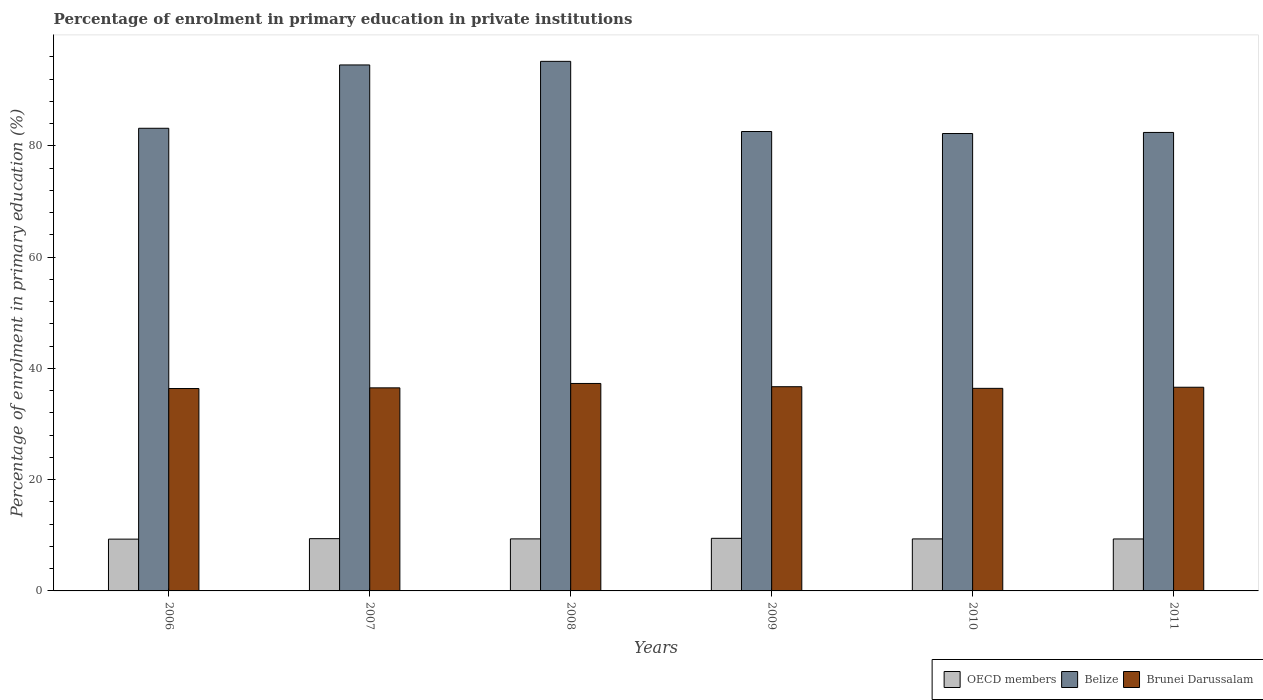How many groups of bars are there?
Keep it short and to the point. 6. Are the number of bars per tick equal to the number of legend labels?
Offer a terse response. Yes. How many bars are there on the 5th tick from the left?
Provide a short and direct response. 3. In how many cases, is the number of bars for a given year not equal to the number of legend labels?
Your response must be concise. 0. What is the percentage of enrolment in primary education in Belize in 2010?
Ensure brevity in your answer.  82.22. Across all years, what is the maximum percentage of enrolment in primary education in Brunei Darussalam?
Your response must be concise. 37.29. Across all years, what is the minimum percentage of enrolment in primary education in Brunei Darussalam?
Ensure brevity in your answer.  36.38. In which year was the percentage of enrolment in primary education in OECD members maximum?
Provide a succinct answer. 2009. What is the total percentage of enrolment in primary education in OECD members in the graph?
Your response must be concise. 56.2. What is the difference between the percentage of enrolment in primary education in Brunei Darussalam in 2007 and that in 2010?
Offer a terse response. 0.09. What is the difference between the percentage of enrolment in primary education in Brunei Darussalam in 2011 and the percentage of enrolment in primary education in Belize in 2008?
Your response must be concise. -58.58. What is the average percentage of enrolment in primary education in OECD members per year?
Your answer should be very brief. 9.37. In the year 2006, what is the difference between the percentage of enrolment in primary education in Brunei Darussalam and percentage of enrolment in primary education in Belize?
Provide a short and direct response. -46.78. What is the ratio of the percentage of enrolment in primary education in Brunei Darussalam in 2007 to that in 2008?
Your answer should be compact. 0.98. Is the percentage of enrolment in primary education in Belize in 2007 less than that in 2011?
Provide a succinct answer. No. Is the difference between the percentage of enrolment in primary education in Brunei Darussalam in 2007 and 2009 greater than the difference between the percentage of enrolment in primary education in Belize in 2007 and 2009?
Your answer should be compact. No. What is the difference between the highest and the second highest percentage of enrolment in primary education in OECD members?
Provide a succinct answer. 0.06. What is the difference between the highest and the lowest percentage of enrolment in primary education in Brunei Darussalam?
Make the answer very short. 0.91. In how many years, is the percentage of enrolment in primary education in OECD members greater than the average percentage of enrolment in primary education in OECD members taken over all years?
Give a very brief answer. 2. Is the sum of the percentage of enrolment in primary education in Belize in 2006 and 2007 greater than the maximum percentage of enrolment in primary education in OECD members across all years?
Provide a short and direct response. Yes. What does the 1st bar from the left in 2008 represents?
Ensure brevity in your answer.  OECD members. What does the 2nd bar from the right in 2007 represents?
Your answer should be compact. Belize. Is it the case that in every year, the sum of the percentage of enrolment in primary education in OECD members and percentage of enrolment in primary education in Brunei Darussalam is greater than the percentage of enrolment in primary education in Belize?
Ensure brevity in your answer.  No. How many bars are there?
Keep it short and to the point. 18. Are the values on the major ticks of Y-axis written in scientific E-notation?
Offer a terse response. No. How many legend labels are there?
Keep it short and to the point. 3. How are the legend labels stacked?
Offer a very short reply. Horizontal. What is the title of the graph?
Make the answer very short. Percentage of enrolment in primary education in private institutions. What is the label or title of the X-axis?
Ensure brevity in your answer.  Years. What is the label or title of the Y-axis?
Provide a short and direct response. Percentage of enrolment in primary education (%). What is the Percentage of enrolment in primary education (%) of OECD members in 2006?
Your answer should be compact. 9.31. What is the Percentage of enrolment in primary education (%) in Belize in 2006?
Offer a terse response. 83.16. What is the Percentage of enrolment in primary education (%) of Brunei Darussalam in 2006?
Your response must be concise. 36.38. What is the Percentage of enrolment in primary education (%) in OECD members in 2007?
Offer a terse response. 9.4. What is the Percentage of enrolment in primary education (%) in Belize in 2007?
Your answer should be compact. 94.55. What is the Percentage of enrolment in primary education (%) of Brunei Darussalam in 2007?
Make the answer very short. 36.5. What is the Percentage of enrolment in primary education (%) of OECD members in 2008?
Keep it short and to the point. 9.35. What is the Percentage of enrolment in primary education (%) in Belize in 2008?
Provide a short and direct response. 95.19. What is the Percentage of enrolment in primary education (%) of Brunei Darussalam in 2008?
Make the answer very short. 37.29. What is the Percentage of enrolment in primary education (%) of OECD members in 2009?
Your answer should be very brief. 9.45. What is the Percentage of enrolment in primary education (%) in Belize in 2009?
Keep it short and to the point. 82.58. What is the Percentage of enrolment in primary education (%) in Brunei Darussalam in 2009?
Your answer should be compact. 36.71. What is the Percentage of enrolment in primary education (%) of OECD members in 2010?
Your answer should be compact. 9.35. What is the Percentage of enrolment in primary education (%) in Belize in 2010?
Offer a very short reply. 82.22. What is the Percentage of enrolment in primary education (%) in Brunei Darussalam in 2010?
Make the answer very short. 36.41. What is the Percentage of enrolment in primary education (%) of OECD members in 2011?
Give a very brief answer. 9.34. What is the Percentage of enrolment in primary education (%) of Belize in 2011?
Ensure brevity in your answer.  82.41. What is the Percentage of enrolment in primary education (%) of Brunei Darussalam in 2011?
Provide a short and direct response. 36.61. Across all years, what is the maximum Percentage of enrolment in primary education (%) of OECD members?
Offer a very short reply. 9.45. Across all years, what is the maximum Percentage of enrolment in primary education (%) in Belize?
Your answer should be compact. 95.19. Across all years, what is the maximum Percentage of enrolment in primary education (%) of Brunei Darussalam?
Offer a terse response. 37.29. Across all years, what is the minimum Percentage of enrolment in primary education (%) in OECD members?
Provide a short and direct response. 9.31. Across all years, what is the minimum Percentage of enrolment in primary education (%) in Belize?
Provide a short and direct response. 82.22. Across all years, what is the minimum Percentage of enrolment in primary education (%) in Brunei Darussalam?
Your answer should be very brief. 36.38. What is the total Percentage of enrolment in primary education (%) in OECD members in the graph?
Give a very brief answer. 56.2. What is the total Percentage of enrolment in primary education (%) of Belize in the graph?
Ensure brevity in your answer.  520.1. What is the total Percentage of enrolment in primary education (%) in Brunei Darussalam in the graph?
Offer a very short reply. 219.91. What is the difference between the Percentage of enrolment in primary education (%) in OECD members in 2006 and that in 2007?
Offer a very short reply. -0.09. What is the difference between the Percentage of enrolment in primary education (%) in Belize in 2006 and that in 2007?
Offer a terse response. -11.38. What is the difference between the Percentage of enrolment in primary education (%) of Brunei Darussalam in 2006 and that in 2007?
Make the answer very short. -0.12. What is the difference between the Percentage of enrolment in primary education (%) in OECD members in 2006 and that in 2008?
Offer a very short reply. -0.05. What is the difference between the Percentage of enrolment in primary education (%) in Belize in 2006 and that in 2008?
Provide a short and direct response. -12.03. What is the difference between the Percentage of enrolment in primary education (%) of Brunei Darussalam in 2006 and that in 2008?
Offer a terse response. -0.91. What is the difference between the Percentage of enrolment in primary education (%) in OECD members in 2006 and that in 2009?
Your answer should be compact. -0.14. What is the difference between the Percentage of enrolment in primary education (%) in Belize in 2006 and that in 2009?
Offer a very short reply. 0.58. What is the difference between the Percentage of enrolment in primary education (%) in Brunei Darussalam in 2006 and that in 2009?
Your answer should be compact. -0.32. What is the difference between the Percentage of enrolment in primary education (%) in OECD members in 2006 and that in 2010?
Offer a terse response. -0.04. What is the difference between the Percentage of enrolment in primary education (%) in Belize in 2006 and that in 2010?
Make the answer very short. 0.95. What is the difference between the Percentage of enrolment in primary education (%) in Brunei Darussalam in 2006 and that in 2010?
Offer a very short reply. -0.03. What is the difference between the Percentage of enrolment in primary education (%) in OECD members in 2006 and that in 2011?
Your answer should be compact. -0.03. What is the difference between the Percentage of enrolment in primary education (%) in Belize in 2006 and that in 2011?
Your answer should be very brief. 0.75. What is the difference between the Percentage of enrolment in primary education (%) of Brunei Darussalam in 2006 and that in 2011?
Offer a terse response. -0.23. What is the difference between the Percentage of enrolment in primary education (%) of OECD members in 2007 and that in 2008?
Provide a short and direct response. 0.04. What is the difference between the Percentage of enrolment in primary education (%) in Belize in 2007 and that in 2008?
Make the answer very short. -0.64. What is the difference between the Percentage of enrolment in primary education (%) in Brunei Darussalam in 2007 and that in 2008?
Your answer should be compact. -0.79. What is the difference between the Percentage of enrolment in primary education (%) of OECD members in 2007 and that in 2009?
Your response must be concise. -0.06. What is the difference between the Percentage of enrolment in primary education (%) of Belize in 2007 and that in 2009?
Offer a very short reply. 11.97. What is the difference between the Percentage of enrolment in primary education (%) in Brunei Darussalam in 2007 and that in 2009?
Your answer should be compact. -0.2. What is the difference between the Percentage of enrolment in primary education (%) of OECD members in 2007 and that in 2010?
Provide a short and direct response. 0.05. What is the difference between the Percentage of enrolment in primary education (%) in Belize in 2007 and that in 2010?
Your response must be concise. 12.33. What is the difference between the Percentage of enrolment in primary education (%) in Brunei Darussalam in 2007 and that in 2010?
Ensure brevity in your answer.  0.09. What is the difference between the Percentage of enrolment in primary education (%) in OECD members in 2007 and that in 2011?
Make the answer very short. 0.06. What is the difference between the Percentage of enrolment in primary education (%) in Belize in 2007 and that in 2011?
Your answer should be compact. 12.13. What is the difference between the Percentage of enrolment in primary education (%) of Brunei Darussalam in 2007 and that in 2011?
Provide a short and direct response. -0.11. What is the difference between the Percentage of enrolment in primary education (%) of OECD members in 2008 and that in 2009?
Provide a succinct answer. -0.1. What is the difference between the Percentage of enrolment in primary education (%) in Belize in 2008 and that in 2009?
Your response must be concise. 12.61. What is the difference between the Percentage of enrolment in primary education (%) of Brunei Darussalam in 2008 and that in 2009?
Keep it short and to the point. 0.59. What is the difference between the Percentage of enrolment in primary education (%) of OECD members in 2008 and that in 2010?
Your response must be concise. 0.01. What is the difference between the Percentage of enrolment in primary education (%) in Belize in 2008 and that in 2010?
Offer a very short reply. 12.97. What is the difference between the Percentage of enrolment in primary education (%) in Brunei Darussalam in 2008 and that in 2010?
Your answer should be compact. 0.88. What is the difference between the Percentage of enrolment in primary education (%) in OECD members in 2008 and that in 2011?
Your answer should be compact. 0.01. What is the difference between the Percentage of enrolment in primary education (%) in Belize in 2008 and that in 2011?
Offer a terse response. 12.78. What is the difference between the Percentage of enrolment in primary education (%) of Brunei Darussalam in 2008 and that in 2011?
Ensure brevity in your answer.  0.68. What is the difference between the Percentage of enrolment in primary education (%) of OECD members in 2009 and that in 2010?
Your answer should be very brief. 0.11. What is the difference between the Percentage of enrolment in primary education (%) in Belize in 2009 and that in 2010?
Make the answer very short. 0.36. What is the difference between the Percentage of enrolment in primary education (%) in Brunei Darussalam in 2009 and that in 2010?
Offer a terse response. 0.3. What is the difference between the Percentage of enrolment in primary education (%) of OECD members in 2009 and that in 2011?
Keep it short and to the point. 0.11. What is the difference between the Percentage of enrolment in primary education (%) in Belize in 2009 and that in 2011?
Provide a short and direct response. 0.17. What is the difference between the Percentage of enrolment in primary education (%) of Brunei Darussalam in 2009 and that in 2011?
Your response must be concise. 0.09. What is the difference between the Percentage of enrolment in primary education (%) of OECD members in 2010 and that in 2011?
Your answer should be compact. 0.01. What is the difference between the Percentage of enrolment in primary education (%) in Belize in 2010 and that in 2011?
Your answer should be compact. -0.19. What is the difference between the Percentage of enrolment in primary education (%) in Brunei Darussalam in 2010 and that in 2011?
Provide a short and direct response. -0.2. What is the difference between the Percentage of enrolment in primary education (%) of OECD members in 2006 and the Percentage of enrolment in primary education (%) of Belize in 2007?
Ensure brevity in your answer.  -85.24. What is the difference between the Percentage of enrolment in primary education (%) of OECD members in 2006 and the Percentage of enrolment in primary education (%) of Brunei Darussalam in 2007?
Make the answer very short. -27.19. What is the difference between the Percentage of enrolment in primary education (%) in Belize in 2006 and the Percentage of enrolment in primary education (%) in Brunei Darussalam in 2007?
Ensure brevity in your answer.  46.66. What is the difference between the Percentage of enrolment in primary education (%) in OECD members in 2006 and the Percentage of enrolment in primary education (%) in Belize in 2008?
Your response must be concise. -85.88. What is the difference between the Percentage of enrolment in primary education (%) in OECD members in 2006 and the Percentage of enrolment in primary education (%) in Brunei Darussalam in 2008?
Make the answer very short. -27.98. What is the difference between the Percentage of enrolment in primary education (%) in Belize in 2006 and the Percentage of enrolment in primary education (%) in Brunei Darussalam in 2008?
Make the answer very short. 45.87. What is the difference between the Percentage of enrolment in primary education (%) in OECD members in 2006 and the Percentage of enrolment in primary education (%) in Belize in 2009?
Keep it short and to the point. -73.27. What is the difference between the Percentage of enrolment in primary education (%) of OECD members in 2006 and the Percentage of enrolment in primary education (%) of Brunei Darussalam in 2009?
Make the answer very short. -27.4. What is the difference between the Percentage of enrolment in primary education (%) of Belize in 2006 and the Percentage of enrolment in primary education (%) of Brunei Darussalam in 2009?
Your answer should be compact. 46.46. What is the difference between the Percentage of enrolment in primary education (%) in OECD members in 2006 and the Percentage of enrolment in primary education (%) in Belize in 2010?
Provide a short and direct response. -72.91. What is the difference between the Percentage of enrolment in primary education (%) in OECD members in 2006 and the Percentage of enrolment in primary education (%) in Brunei Darussalam in 2010?
Provide a short and direct response. -27.1. What is the difference between the Percentage of enrolment in primary education (%) in Belize in 2006 and the Percentage of enrolment in primary education (%) in Brunei Darussalam in 2010?
Your answer should be compact. 46.75. What is the difference between the Percentage of enrolment in primary education (%) in OECD members in 2006 and the Percentage of enrolment in primary education (%) in Belize in 2011?
Give a very brief answer. -73.1. What is the difference between the Percentage of enrolment in primary education (%) of OECD members in 2006 and the Percentage of enrolment in primary education (%) of Brunei Darussalam in 2011?
Your response must be concise. -27.3. What is the difference between the Percentage of enrolment in primary education (%) of Belize in 2006 and the Percentage of enrolment in primary education (%) of Brunei Darussalam in 2011?
Keep it short and to the point. 46.55. What is the difference between the Percentage of enrolment in primary education (%) in OECD members in 2007 and the Percentage of enrolment in primary education (%) in Belize in 2008?
Your answer should be compact. -85.79. What is the difference between the Percentage of enrolment in primary education (%) of OECD members in 2007 and the Percentage of enrolment in primary education (%) of Brunei Darussalam in 2008?
Your response must be concise. -27.9. What is the difference between the Percentage of enrolment in primary education (%) in Belize in 2007 and the Percentage of enrolment in primary education (%) in Brunei Darussalam in 2008?
Your answer should be compact. 57.25. What is the difference between the Percentage of enrolment in primary education (%) of OECD members in 2007 and the Percentage of enrolment in primary education (%) of Belize in 2009?
Offer a terse response. -73.18. What is the difference between the Percentage of enrolment in primary education (%) of OECD members in 2007 and the Percentage of enrolment in primary education (%) of Brunei Darussalam in 2009?
Give a very brief answer. -27.31. What is the difference between the Percentage of enrolment in primary education (%) in Belize in 2007 and the Percentage of enrolment in primary education (%) in Brunei Darussalam in 2009?
Keep it short and to the point. 57.84. What is the difference between the Percentage of enrolment in primary education (%) of OECD members in 2007 and the Percentage of enrolment in primary education (%) of Belize in 2010?
Your response must be concise. -72.82. What is the difference between the Percentage of enrolment in primary education (%) of OECD members in 2007 and the Percentage of enrolment in primary education (%) of Brunei Darussalam in 2010?
Give a very brief answer. -27.01. What is the difference between the Percentage of enrolment in primary education (%) in Belize in 2007 and the Percentage of enrolment in primary education (%) in Brunei Darussalam in 2010?
Your response must be concise. 58.13. What is the difference between the Percentage of enrolment in primary education (%) in OECD members in 2007 and the Percentage of enrolment in primary education (%) in Belize in 2011?
Offer a terse response. -73.01. What is the difference between the Percentage of enrolment in primary education (%) in OECD members in 2007 and the Percentage of enrolment in primary education (%) in Brunei Darussalam in 2011?
Provide a succinct answer. -27.22. What is the difference between the Percentage of enrolment in primary education (%) in Belize in 2007 and the Percentage of enrolment in primary education (%) in Brunei Darussalam in 2011?
Keep it short and to the point. 57.93. What is the difference between the Percentage of enrolment in primary education (%) of OECD members in 2008 and the Percentage of enrolment in primary education (%) of Belize in 2009?
Provide a succinct answer. -73.23. What is the difference between the Percentage of enrolment in primary education (%) in OECD members in 2008 and the Percentage of enrolment in primary education (%) in Brunei Darussalam in 2009?
Your answer should be very brief. -27.35. What is the difference between the Percentage of enrolment in primary education (%) of Belize in 2008 and the Percentage of enrolment in primary education (%) of Brunei Darussalam in 2009?
Your answer should be compact. 58.48. What is the difference between the Percentage of enrolment in primary education (%) in OECD members in 2008 and the Percentage of enrolment in primary education (%) in Belize in 2010?
Ensure brevity in your answer.  -72.86. What is the difference between the Percentage of enrolment in primary education (%) of OECD members in 2008 and the Percentage of enrolment in primary education (%) of Brunei Darussalam in 2010?
Ensure brevity in your answer.  -27.06. What is the difference between the Percentage of enrolment in primary education (%) in Belize in 2008 and the Percentage of enrolment in primary education (%) in Brunei Darussalam in 2010?
Your response must be concise. 58.78. What is the difference between the Percentage of enrolment in primary education (%) of OECD members in 2008 and the Percentage of enrolment in primary education (%) of Belize in 2011?
Your response must be concise. -73.06. What is the difference between the Percentage of enrolment in primary education (%) of OECD members in 2008 and the Percentage of enrolment in primary education (%) of Brunei Darussalam in 2011?
Offer a terse response. -27.26. What is the difference between the Percentage of enrolment in primary education (%) in Belize in 2008 and the Percentage of enrolment in primary education (%) in Brunei Darussalam in 2011?
Your response must be concise. 58.58. What is the difference between the Percentage of enrolment in primary education (%) in OECD members in 2009 and the Percentage of enrolment in primary education (%) in Belize in 2010?
Keep it short and to the point. -72.76. What is the difference between the Percentage of enrolment in primary education (%) of OECD members in 2009 and the Percentage of enrolment in primary education (%) of Brunei Darussalam in 2010?
Your answer should be very brief. -26.96. What is the difference between the Percentage of enrolment in primary education (%) in Belize in 2009 and the Percentage of enrolment in primary education (%) in Brunei Darussalam in 2010?
Provide a succinct answer. 46.17. What is the difference between the Percentage of enrolment in primary education (%) of OECD members in 2009 and the Percentage of enrolment in primary education (%) of Belize in 2011?
Your response must be concise. -72.96. What is the difference between the Percentage of enrolment in primary education (%) in OECD members in 2009 and the Percentage of enrolment in primary education (%) in Brunei Darussalam in 2011?
Your response must be concise. -27.16. What is the difference between the Percentage of enrolment in primary education (%) in Belize in 2009 and the Percentage of enrolment in primary education (%) in Brunei Darussalam in 2011?
Make the answer very short. 45.97. What is the difference between the Percentage of enrolment in primary education (%) in OECD members in 2010 and the Percentage of enrolment in primary education (%) in Belize in 2011?
Provide a succinct answer. -73.06. What is the difference between the Percentage of enrolment in primary education (%) in OECD members in 2010 and the Percentage of enrolment in primary education (%) in Brunei Darussalam in 2011?
Make the answer very short. -27.26. What is the difference between the Percentage of enrolment in primary education (%) of Belize in 2010 and the Percentage of enrolment in primary education (%) of Brunei Darussalam in 2011?
Provide a succinct answer. 45.6. What is the average Percentage of enrolment in primary education (%) in OECD members per year?
Give a very brief answer. 9.37. What is the average Percentage of enrolment in primary education (%) of Belize per year?
Ensure brevity in your answer.  86.68. What is the average Percentage of enrolment in primary education (%) in Brunei Darussalam per year?
Provide a short and direct response. 36.65. In the year 2006, what is the difference between the Percentage of enrolment in primary education (%) in OECD members and Percentage of enrolment in primary education (%) in Belize?
Offer a very short reply. -73.85. In the year 2006, what is the difference between the Percentage of enrolment in primary education (%) in OECD members and Percentage of enrolment in primary education (%) in Brunei Darussalam?
Keep it short and to the point. -27.07. In the year 2006, what is the difference between the Percentage of enrolment in primary education (%) in Belize and Percentage of enrolment in primary education (%) in Brunei Darussalam?
Your answer should be compact. 46.78. In the year 2007, what is the difference between the Percentage of enrolment in primary education (%) in OECD members and Percentage of enrolment in primary education (%) in Belize?
Offer a terse response. -85.15. In the year 2007, what is the difference between the Percentage of enrolment in primary education (%) of OECD members and Percentage of enrolment in primary education (%) of Brunei Darussalam?
Offer a terse response. -27.11. In the year 2007, what is the difference between the Percentage of enrolment in primary education (%) of Belize and Percentage of enrolment in primary education (%) of Brunei Darussalam?
Your answer should be compact. 58.04. In the year 2008, what is the difference between the Percentage of enrolment in primary education (%) of OECD members and Percentage of enrolment in primary education (%) of Belize?
Offer a terse response. -85.84. In the year 2008, what is the difference between the Percentage of enrolment in primary education (%) in OECD members and Percentage of enrolment in primary education (%) in Brunei Darussalam?
Give a very brief answer. -27.94. In the year 2008, what is the difference between the Percentage of enrolment in primary education (%) of Belize and Percentage of enrolment in primary education (%) of Brunei Darussalam?
Keep it short and to the point. 57.9. In the year 2009, what is the difference between the Percentage of enrolment in primary education (%) in OECD members and Percentage of enrolment in primary education (%) in Belize?
Your answer should be very brief. -73.13. In the year 2009, what is the difference between the Percentage of enrolment in primary education (%) in OECD members and Percentage of enrolment in primary education (%) in Brunei Darussalam?
Offer a terse response. -27.25. In the year 2009, what is the difference between the Percentage of enrolment in primary education (%) in Belize and Percentage of enrolment in primary education (%) in Brunei Darussalam?
Your response must be concise. 45.87. In the year 2010, what is the difference between the Percentage of enrolment in primary education (%) in OECD members and Percentage of enrolment in primary education (%) in Belize?
Your answer should be compact. -72.87. In the year 2010, what is the difference between the Percentage of enrolment in primary education (%) of OECD members and Percentage of enrolment in primary education (%) of Brunei Darussalam?
Ensure brevity in your answer.  -27.06. In the year 2010, what is the difference between the Percentage of enrolment in primary education (%) of Belize and Percentage of enrolment in primary education (%) of Brunei Darussalam?
Your answer should be very brief. 45.81. In the year 2011, what is the difference between the Percentage of enrolment in primary education (%) in OECD members and Percentage of enrolment in primary education (%) in Belize?
Give a very brief answer. -73.07. In the year 2011, what is the difference between the Percentage of enrolment in primary education (%) in OECD members and Percentage of enrolment in primary education (%) in Brunei Darussalam?
Keep it short and to the point. -27.27. In the year 2011, what is the difference between the Percentage of enrolment in primary education (%) in Belize and Percentage of enrolment in primary education (%) in Brunei Darussalam?
Keep it short and to the point. 45.8. What is the ratio of the Percentage of enrolment in primary education (%) in OECD members in 2006 to that in 2007?
Your response must be concise. 0.99. What is the ratio of the Percentage of enrolment in primary education (%) of Belize in 2006 to that in 2007?
Your response must be concise. 0.88. What is the ratio of the Percentage of enrolment in primary education (%) in OECD members in 2006 to that in 2008?
Ensure brevity in your answer.  1. What is the ratio of the Percentage of enrolment in primary education (%) of Belize in 2006 to that in 2008?
Your answer should be very brief. 0.87. What is the ratio of the Percentage of enrolment in primary education (%) of Brunei Darussalam in 2006 to that in 2008?
Offer a very short reply. 0.98. What is the ratio of the Percentage of enrolment in primary education (%) of OECD members in 2006 to that in 2009?
Your answer should be compact. 0.98. What is the ratio of the Percentage of enrolment in primary education (%) in Belize in 2006 to that in 2010?
Make the answer very short. 1.01. What is the ratio of the Percentage of enrolment in primary education (%) of OECD members in 2006 to that in 2011?
Offer a terse response. 1. What is the ratio of the Percentage of enrolment in primary education (%) in Belize in 2006 to that in 2011?
Make the answer very short. 1.01. What is the ratio of the Percentage of enrolment in primary education (%) of Brunei Darussalam in 2006 to that in 2011?
Make the answer very short. 0.99. What is the ratio of the Percentage of enrolment in primary education (%) of OECD members in 2007 to that in 2008?
Offer a terse response. 1. What is the ratio of the Percentage of enrolment in primary education (%) in Belize in 2007 to that in 2008?
Ensure brevity in your answer.  0.99. What is the ratio of the Percentage of enrolment in primary education (%) in Brunei Darussalam in 2007 to that in 2008?
Give a very brief answer. 0.98. What is the ratio of the Percentage of enrolment in primary education (%) in Belize in 2007 to that in 2009?
Your answer should be compact. 1.14. What is the ratio of the Percentage of enrolment in primary education (%) in OECD members in 2007 to that in 2010?
Make the answer very short. 1.01. What is the ratio of the Percentage of enrolment in primary education (%) of Belize in 2007 to that in 2010?
Provide a succinct answer. 1.15. What is the ratio of the Percentage of enrolment in primary education (%) of Brunei Darussalam in 2007 to that in 2010?
Offer a terse response. 1. What is the ratio of the Percentage of enrolment in primary education (%) of Belize in 2007 to that in 2011?
Give a very brief answer. 1.15. What is the ratio of the Percentage of enrolment in primary education (%) in Brunei Darussalam in 2007 to that in 2011?
Give a very brief answer. 1. What is the ratio of the Percentage of enrolment in primary education (%) in OECD members in 2008 to that in 2009?
Offer a very short reply. 0.99. What is the ratio of the Percentage of enrolment in primary education (%) in Belize in 2008 to that in 2009?
Give a very brief answer. 1.15. What is the ratio of the Percentage of enrolment in primary education (%) of Brunei Darussalam in 2008 to that in 2009?
Give a very brief answer. 1.02. What is the ratio of the Percentage of enrolment in primary education (%) in Belize in 2008 to that in 2010?
Your response must be concise. 1.16. What is the ratio of the Percentage of enrolment in primary education (%) in Brunei Darussalam in 2008 to that in 2010?
Make the answer very short. 1.02. What is the ratio of the Percentage of enrolment in primary education (%) of Belize in 2008 to that in 2011?
Your answer should be compact. 1.16. What is the ratio of the Percentage of enrolment in primary education (%) of Brunei Darussalam in 2008 to that in 2011?
Ensure brevity in your answer.  1.02. What is the ratio of the Percentage of enrolment in primary education (%) of OECD members in 2009 to that in 2010?
Provide a succinct answer. 1.01. What is the ratio of the Percentage of enrolment in primary education (%) of Brunei Darussalam in 2009 to that in 2010?
Offer a very short reply. 1.01. What is the ratio of the Percentage of enrolment in primary education (%) of OECD members in 2009 to that in 2011?
Keep it short and to the point. 1.01. What is the ratio of the Percentage of enrolment in primary education (%) in Belize in 2009 to that in 2011?
Ensure brevity in your answer.  1. What is the ratio of the Percentage of enrolment in primary education (%) of OECD members in 2010 to that in 2011?
Ensure brevity in your answer.  1. What is the ratio of the Percentage of enrolment in primary education (%) of Belize in 2010 to that in 2011?
Offer a very short reply. 1. What is the ratio of the Percentage of enrolment in primary education (%) of Brunei Darussalam in 2010 to that in 2011?
Provide a short and direct response. 0.99. What is the difference between the highest and the second highest Percentage of enrolment in primary education (%) in OECD members?
Make the answer very short. 0.06. What is the difference between the highest and the second highest Percentage of enrolment in primary education (%) of Belize?
Your response must be concise. 0.64. What is the difference between the highest and the second highest Percentage of enrolment in primary education (%) of Brunei Darussalam?
Provide a succinct answer. 0.59. What is the difference between the highest and the lowest Percentage of enrolment in primary education (%) in OECD members?
Give a very brief answer. 0.14. What is the difference between the highest and the lowest Percentage of enrolment in primary education (%) of Belize?
Keep it short and to the point. 12.97. What is the difference between the highest and the lowest Percentage of enrolment in primary education (%) in Brunei Darussalam?
Provide a short and direct response. 0.91. 